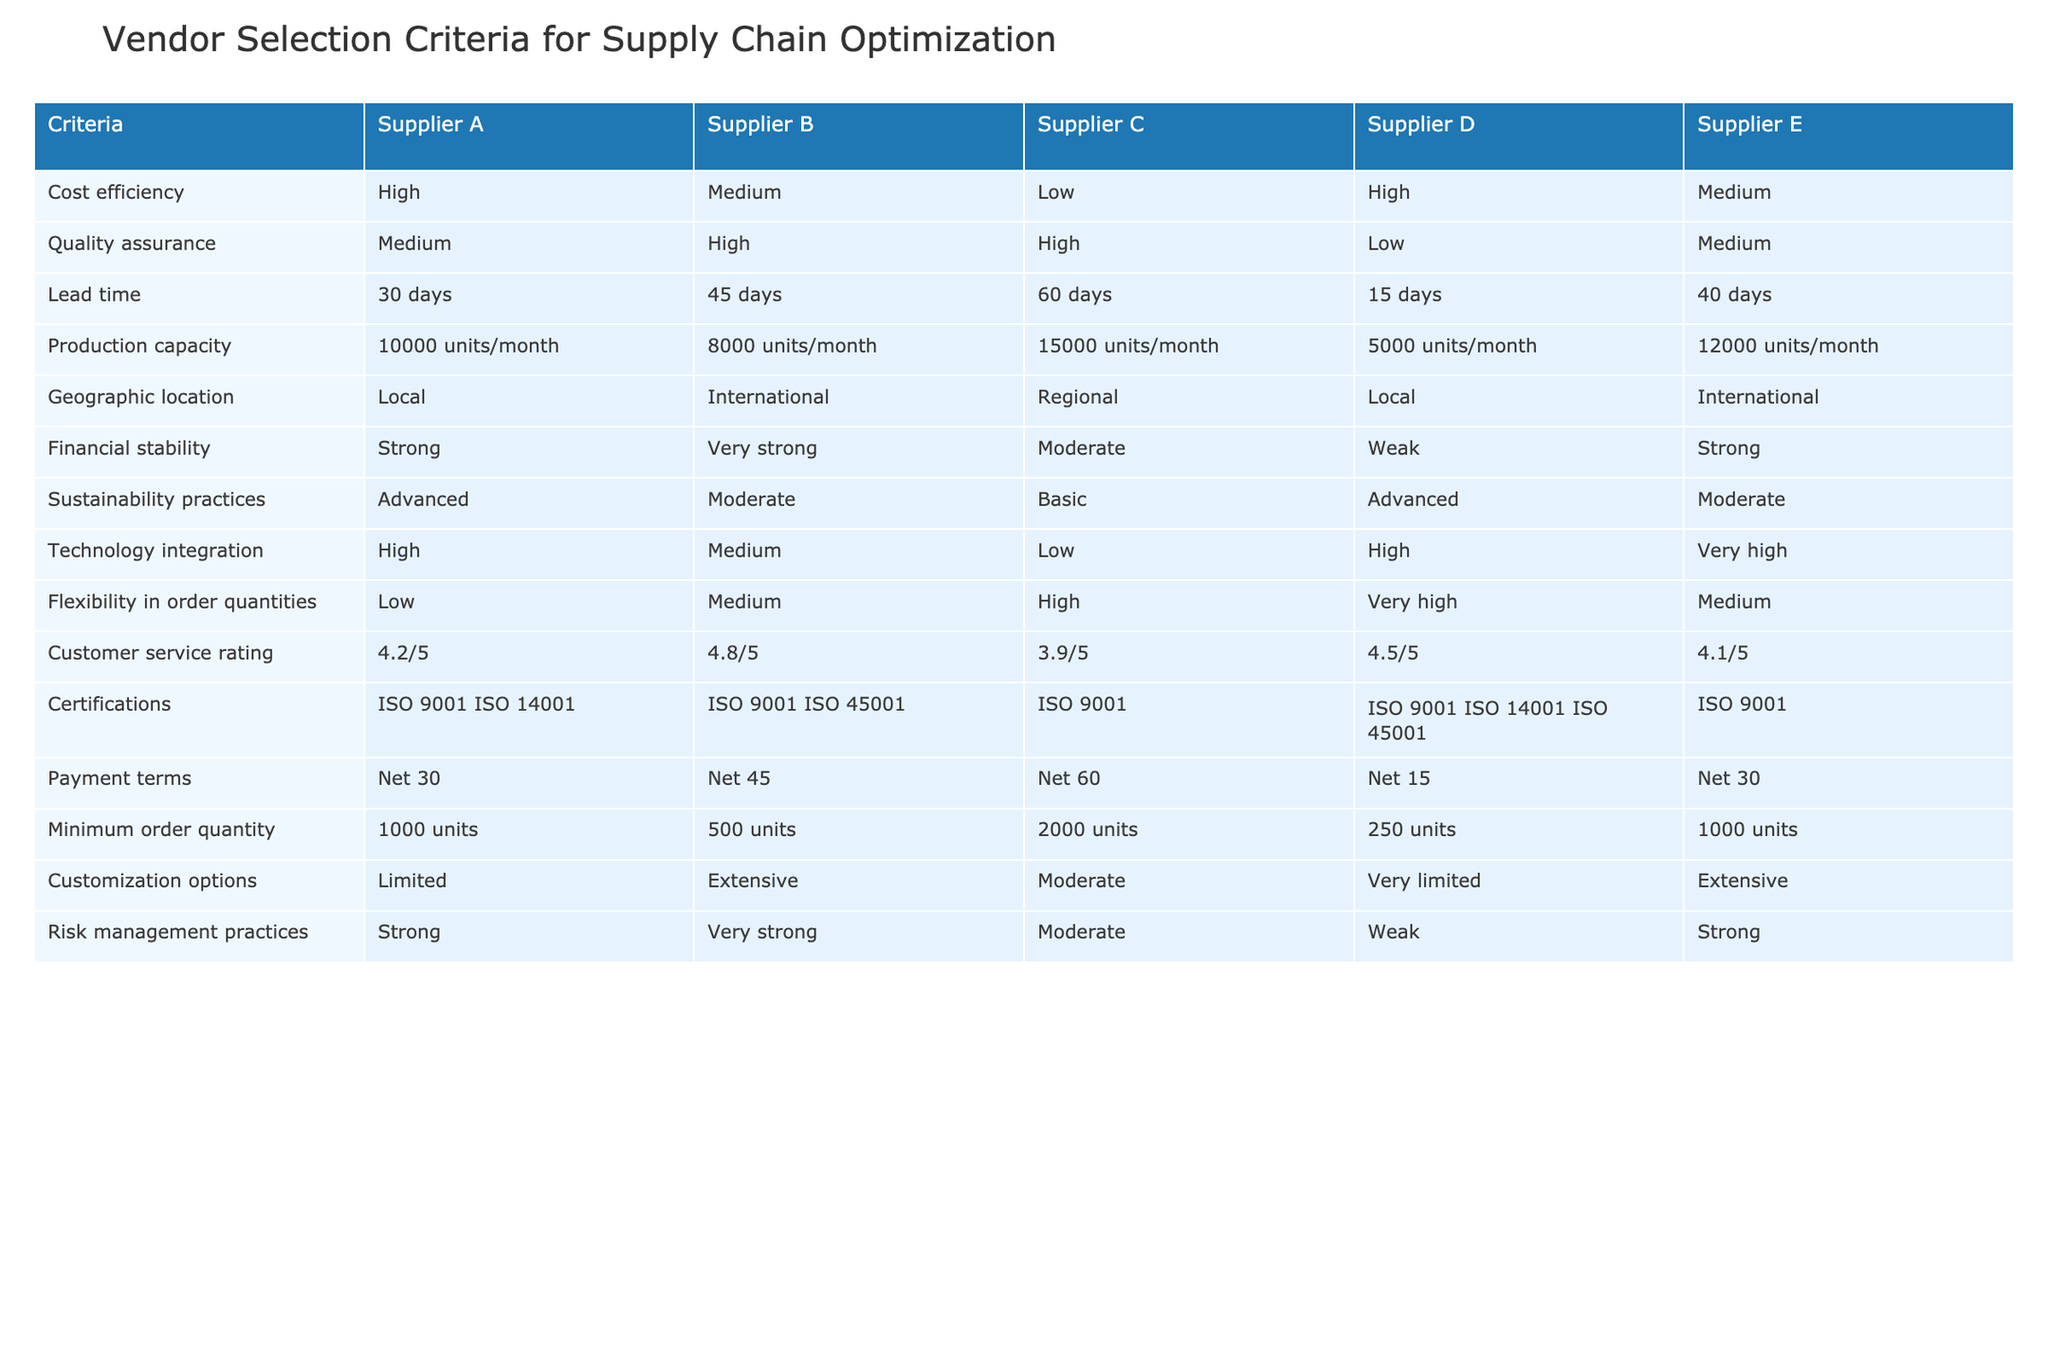What is the lead time for Supplier D? The table indicates the lead time for Supplier D in the "Lead time" row, where it shows "15 days."
Answer: 15 days Which supplier has the highest customer service rating? The customer service ratings for each supplier can be found in the "Customer service rating" row. Supplier B has the highest rating at "4.8/5."
Answer: Supplier B Does Supplier C have the highest production capacity? In the "Production capacity" row, Supplier C is listed with "15000 units/month," which is the largest capacity compared to the others. Therefore, Supplier C indeed has the highest production capacity.
Answer: Yes What is the minimum order quantity for Supplier B? The "Minimum order quantity" row shows "500 units" for Supplier B.
Answer: 500 units Which suppliers offer advanced sustainability practices? By checking the "Sustainability practices" row, we see that Supplier A and Supplier D are both labeled as "Advanced."
Answer: Supplier A and Supplier D What is the average customer service rating of the suppliers that have a 'Medium' rating in quality assurance? The suppliers with a 'Medium' rating in the "Quality assurance" row are Supplier A and Supplier E with customer service ratings of "4.2/5" and "4.1/5" respectively. To find the average, we sum the ratings (4.2 + 4.1) = 8.3, then divide by 2 for the average. This results in 8.3/2 = 4.15.
Answer: 4.15 Is it true that only Supplier C has basic sustainability practices? Checking the "Sustainability practices" row, Supplier C is marked as "Basic," while others such as Supplier A and Supplier D are labeled as "Advanced." Therefore, it is not correct since other suppliers do not have basic practices.
Answer: No Which supplier has the strongest financial stability? Looking at the "Financial stability" row, Supplier B with "Very strong" is the one with the strongest financial stability among the listed suppliers.
Answer: Supplier B What are the geographic locations of Suppliers A and D? From the "Geographic location" row, Supplier A is listed as "Local" and Supplier D is also "Local."
Answer: Local, Local 